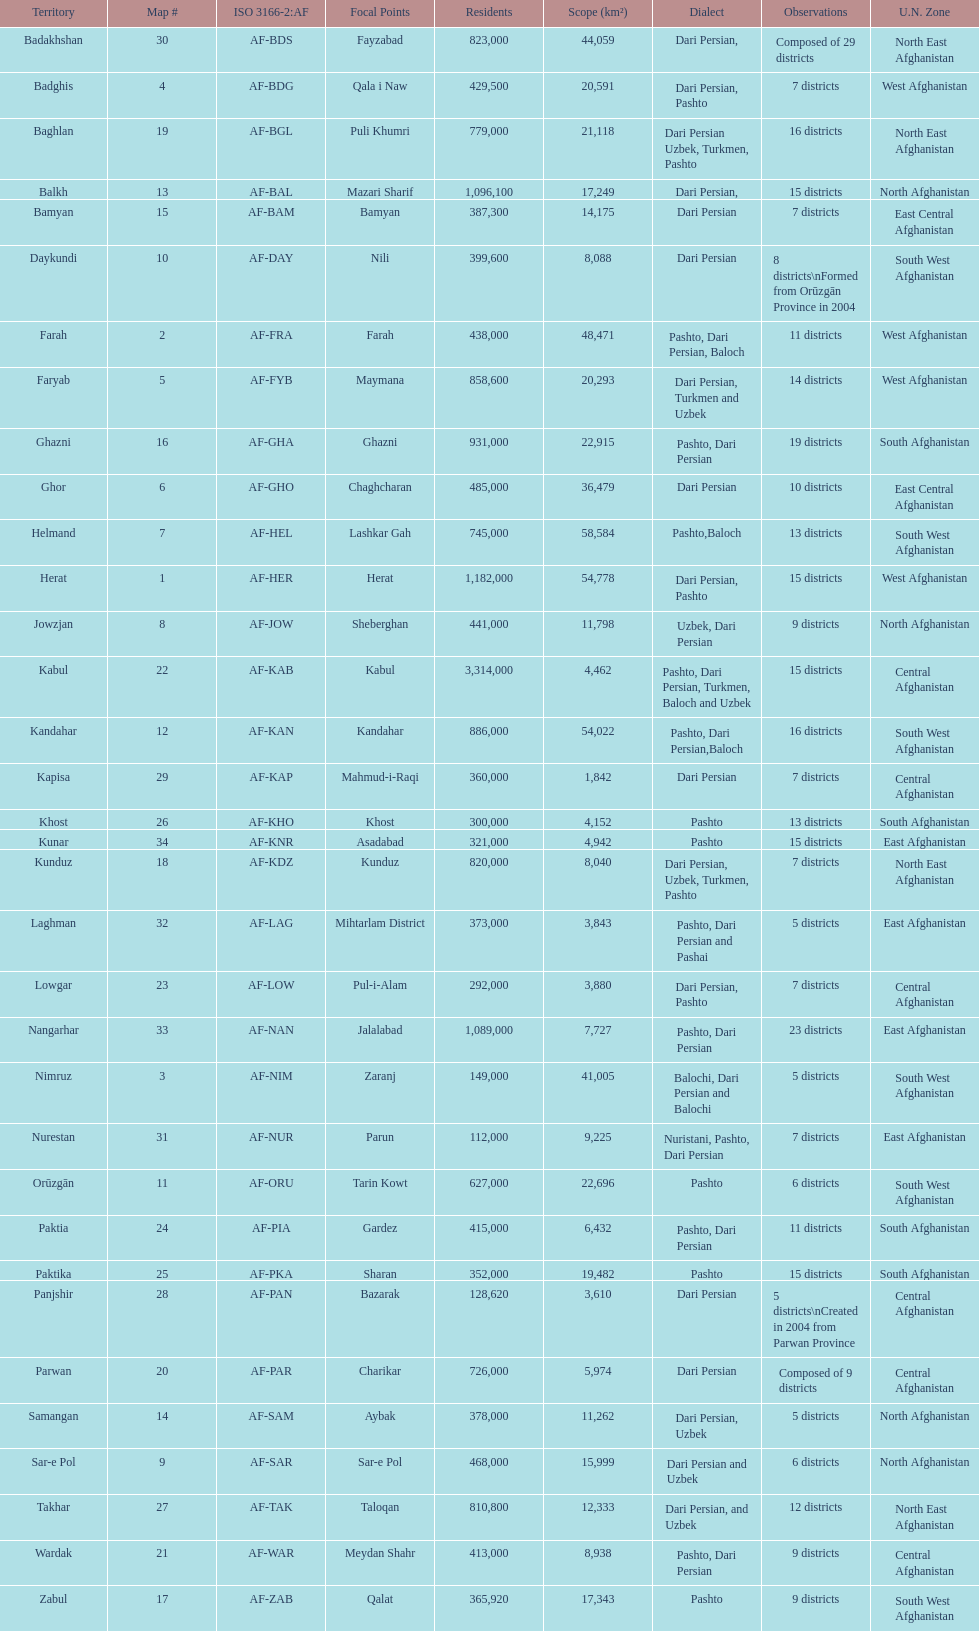Give the province with the least population Nurestan. 